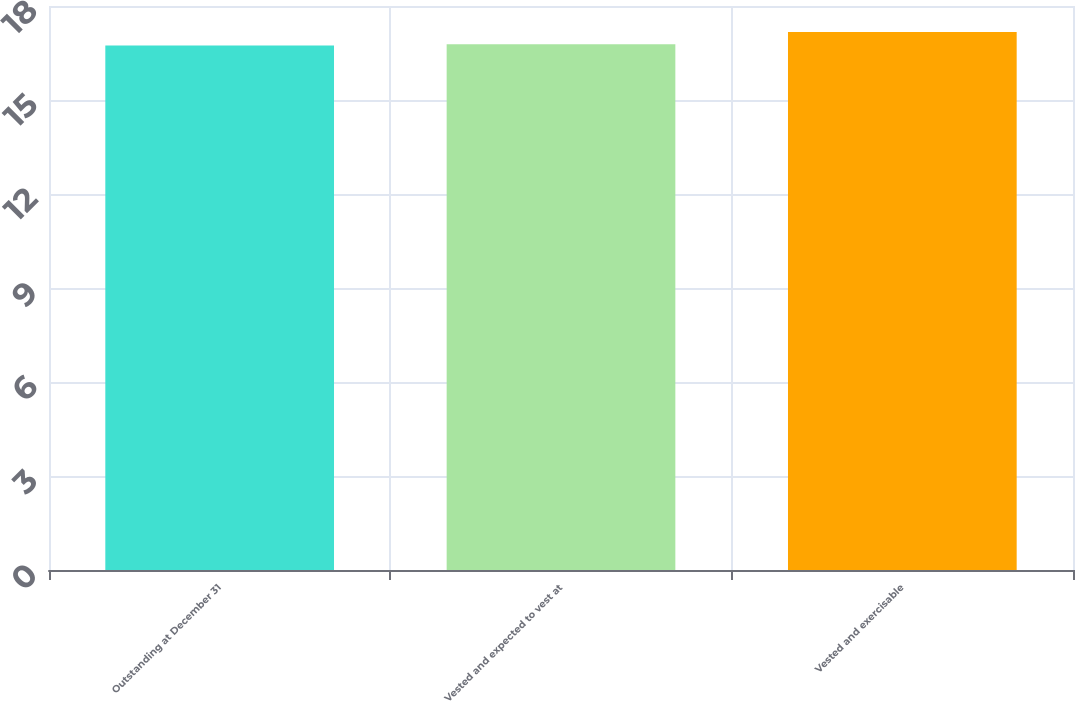<chart> <loc_0><loc_0><loc_500><loc_500><bar_chart><fcel>Outstanding at December 31<fcel>Vested and expected to vest at<fcel>Vested and exercisable<nl><fcel>16.74<fcel>16.78<fcel>17.17<nl></chart> 